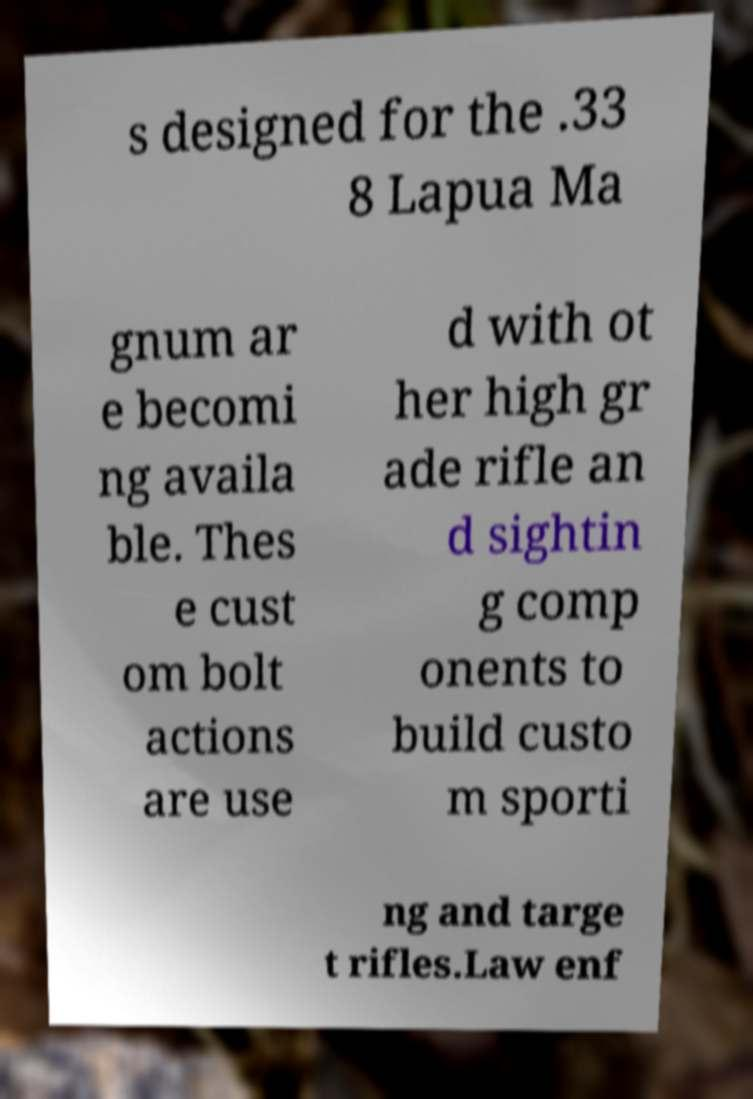Could you extract and type out the text from this image? s designed for the .33 8 Lapua Ma gnum ar e becomi ng availa ble. Thes e cust om bolt actions are use d with ot her high gr ade rifle an d sightin g comp onents to build custo m sporti ng and targe t rifles.Law enf 